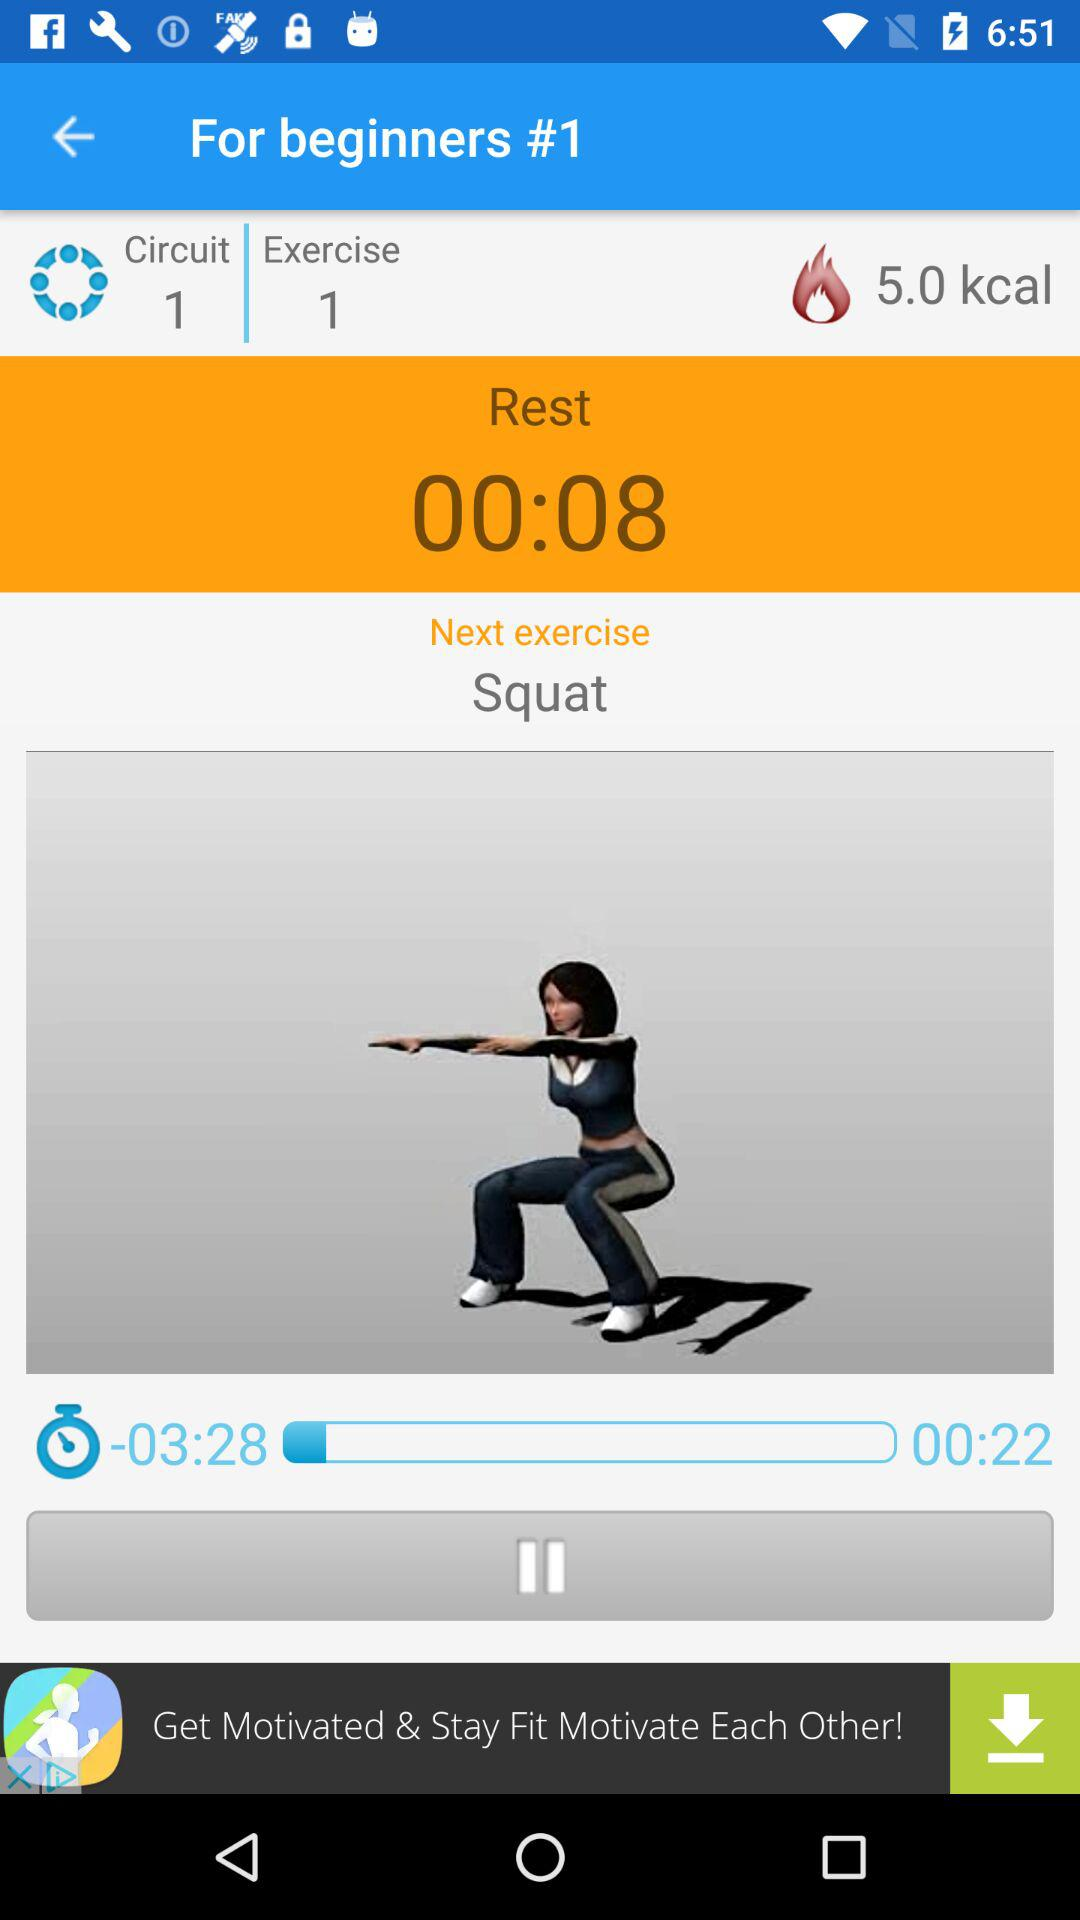What's the next exercise? The next exercise is the squat. 